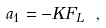Convert formula to latex. <formula><loc_0><loc_0><loc_500><loc_500>\ \ a _ { 1 } = - K { F _ { L } } \ ,</formula> 